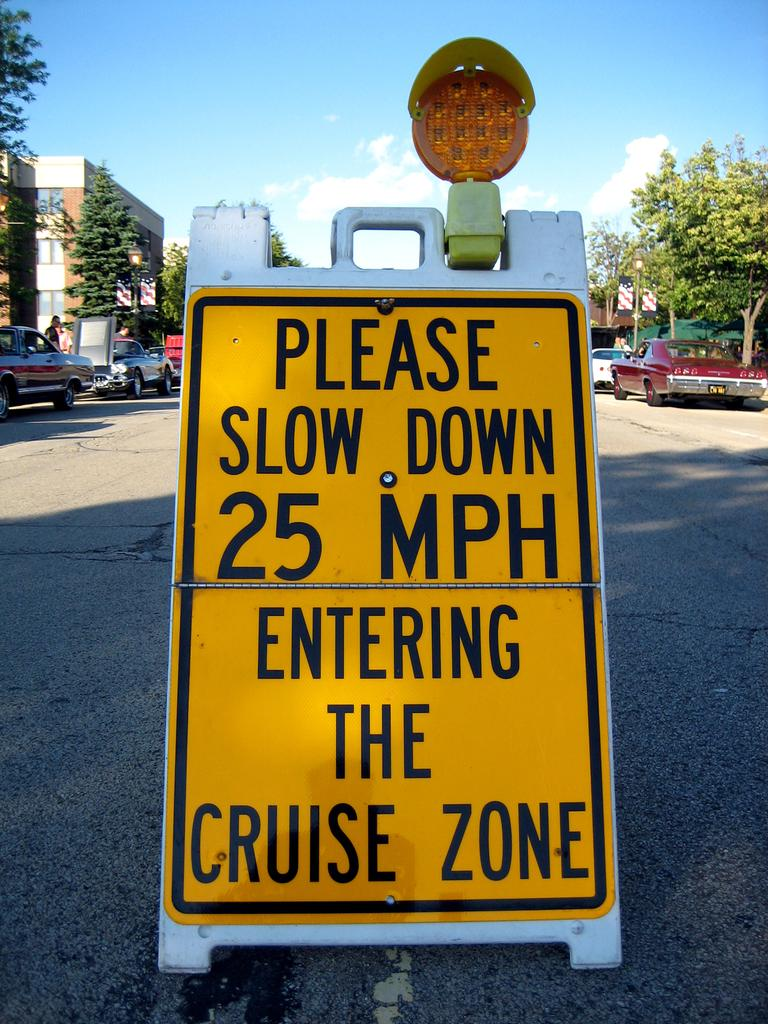<image>
Summarize the visual content of the image. A warning sign that tells drivers to slow down to 25 MPH 